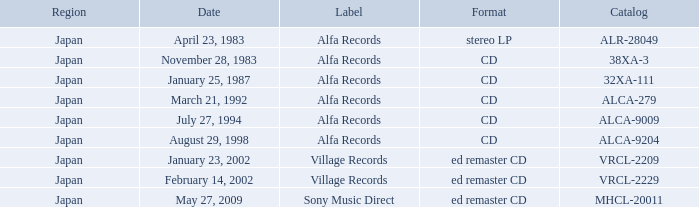Which catalog is in cd format? 38XA-3, 32XA-111, ALCA-279, ALCA-9009, ALCA-9204. 